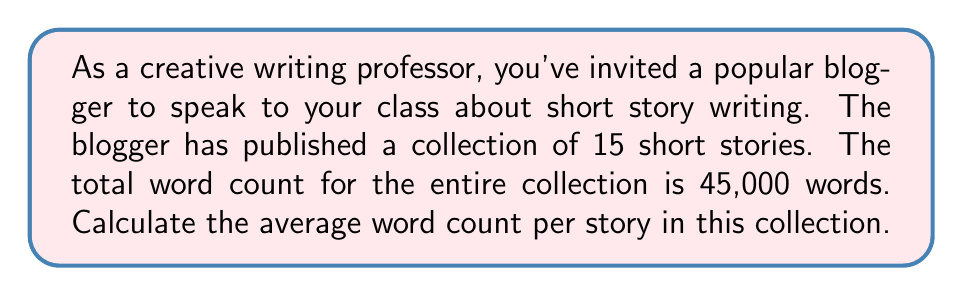Solve this math problem. To find the average word count per story, we need to divide the total word count by the number of stories. Let's break it down step-by-step:

1. Given information:
   - Total number of stories: $n = 15$
   - Total word count: $w = 45,000$

2. The formula for calculating the average is:
   $$ \text{Average} = \frac{\text{Sum of values}}{\text{Number of values}} $$

3. In this case, we can express it as:
   $$ \text{Average word count} = \frac{\text{Total word count}}{\text{Number of stories}} $$

4. Substituting the values:
   $$ \text{Average word count} = \frac{45,000}{15} $$

5. Performing the division:
   $$ \text{Average word count} = 3,000 $$

Therefore, the average word count per story in the blogger's collection is 3,000 words.
Answer: 3,000 words 